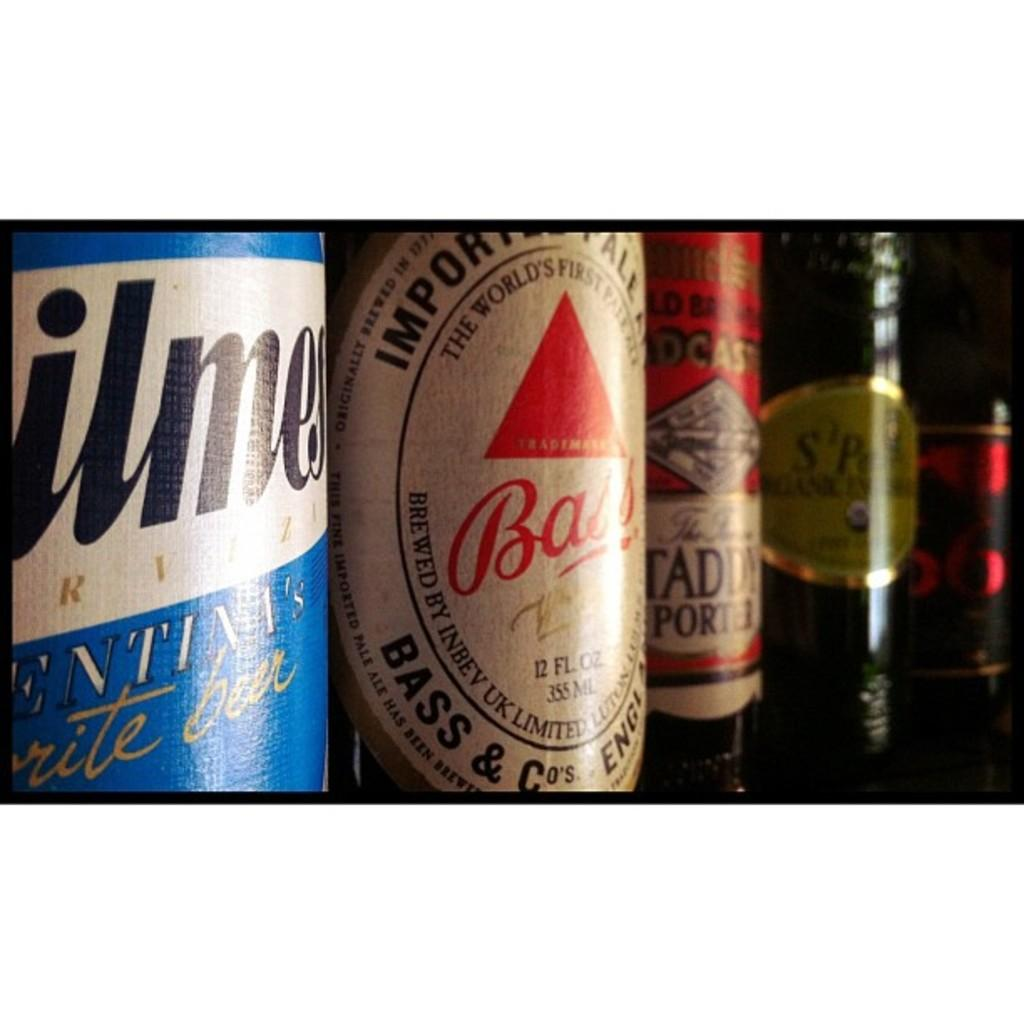<image>
Provide a brief description of the given image. A bottle of Bass beer stands alongside some other beers. 